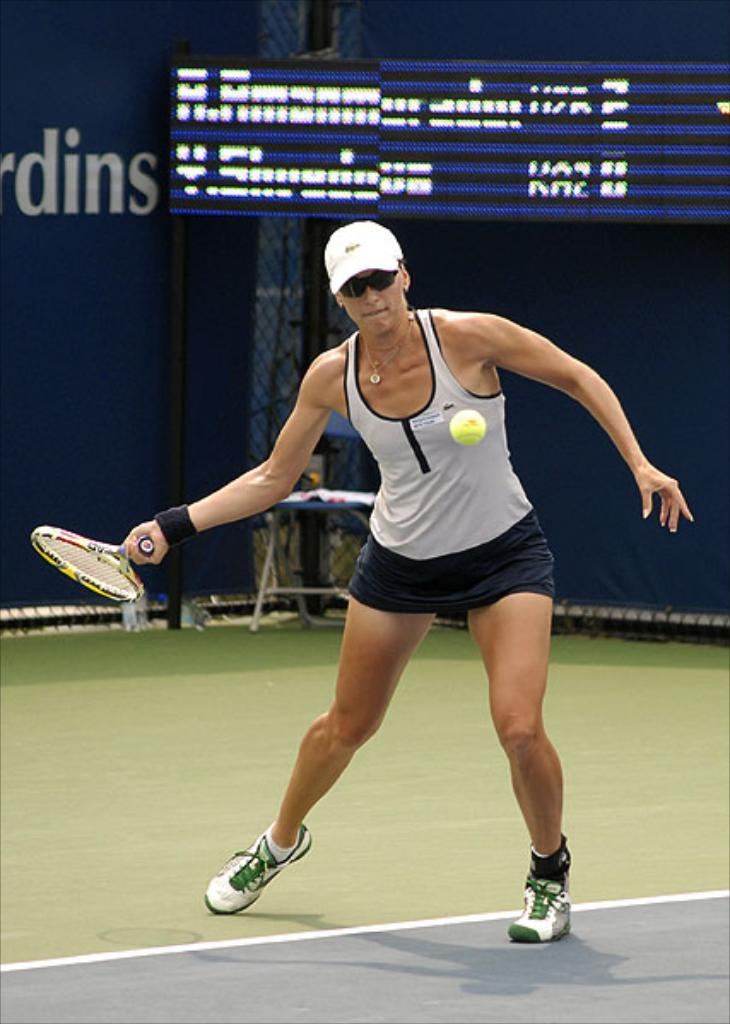Who is the main subject in the image? There is a woman in the image. What is the woman doing in the image? The woman is playing badminton. What can be seen in the background of the image? The background of the image is dark. What is the woman holding in the image? The woman is holding a badminton racket. What else is visible in the image besides the woman and her racket? The badminton court and a display are visible in the image. What degree of anger is the woman expressing in the image? There is no indication of the woman's emotional state in the image, so it cannot be determined whether she is expressing anger or any other emotion. 